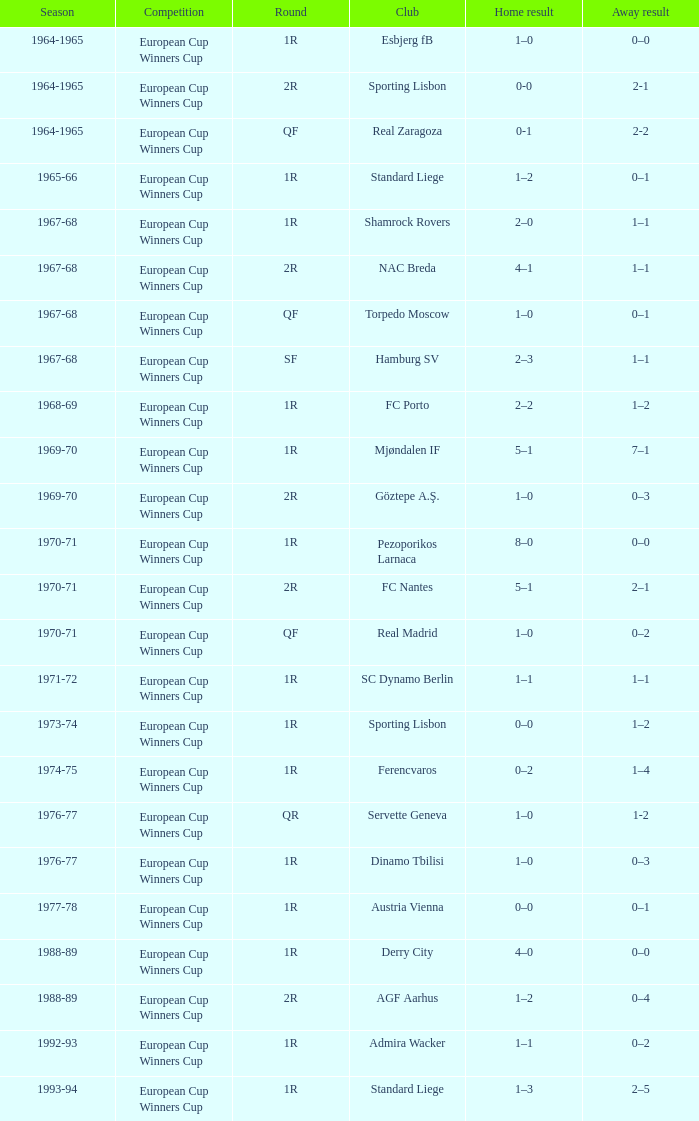What team experiences a 1-0 win at home and a 1-0 loss away? Torpedo Moscow. 